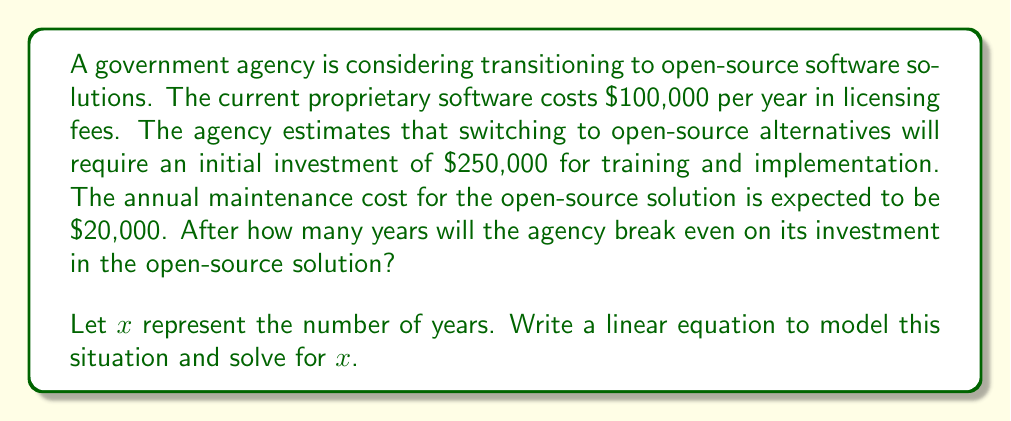What is the answer to this math problem? To solve this problem, we need to set up a linear equation that compares the total cost of the proprietary solution with the total cost of the open-source solution over $x$ years.

1. Cost of proprietary solution over $x$ years:
   $$ 100,000x $$

2. Cost of open-source solution over $x$ years:
   $$ 250,000 + 20,000x $$

3. At the break-even point, these costs are equal:
   $$ 100,000x = 250,000 + 20,000x $$

4. Solve the equation for $x$:
   $$ 100,000x - 20,000x = 250,000 $$
   $$ 80,000x = 250,000 $$
   $$ x = \frac{250,000}{80,000} = 3.125 $$

5. Since we can't have a fractional year, we round up to the nearest whole year.

The agency will break even after 4 years of using the open-source solution.

To verify:
- Proprietary cost after 4 years: $100,000 * 4 = $400,000
- Open-source cost after 4 years: $250,000 + ($20,000 * 4) = $330,000

After 4 years, the open-source solution becomes more cost-effective.
Answer: The agency will break even on its investment in the open-source solution after 4 years. 